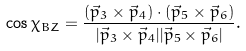<formula> <loc_0><loc_0><loc_500><loc_500>\cos \chi _ { B Z } = \frac { ( \vec { p } _ { 3 } \times \vec { p } _ { 4 } ) \cdot ( \vec { p } _ { 5 } \times \vec { p } _ { 6 } ) } { | \vec { p } _ { 3 } \times \vec { p } _ { 4 } | | \vec { p } _ { 5 } \times \vec { p } _ { 6 } | } .</formula> 